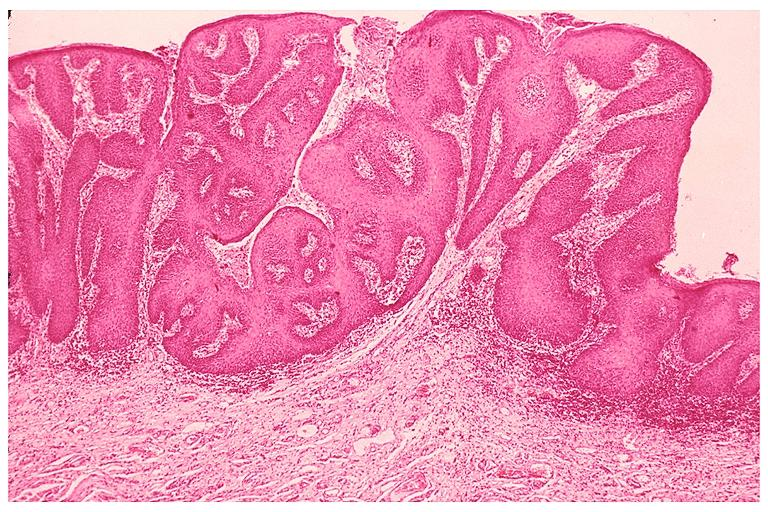what does this image show?
Answer the question using a single word or phrase. Inflamatory papillary hyperplasia 